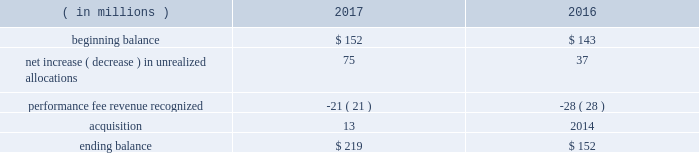When the likelihood of clawback is considered mathematically improbable .
The company records a deferred carried interest liability to the extent it receives cash or capital allocations related to carried interest prior to meeting the revenue recognition criteria .
At december 31 , 2017 and 2016 , the company had $ 219 million and $ 152 million , respectively , of deferred carried interest recorded in other liabilities/other liabilities of consolidated vies on the consolidated statements of financial condition .
A portion of the deferred carried interest liability will be paid to certain employees .
The ultimate timing of the recognition of performance fee revenue , if any , for these products is unknown .
The table presents changes in the deferred carried interest liability ( including the portion related to consolidated vies ) for 2017 and 2016: .
For 2017 , 2016 and 2015 , performance fee revenue ( which included recognized carried interest ) totaled $ 594 million , $ 295 million and $ 621 million , respectively .
Fees earned for technology and risk management revenue are recorded as services are performed and are generally determined using the value of positions on the aladdin platform or on a fixed-rate basis .
For 2017 , 2016 and 2016 , technology and risk management revenue totaled $ 677 million , $ 595 million and $ 528 million , respectively .
Adjustments to revenue arising from initial estimates recorded historically have been immaterial since the majority of blackrock 2019s investment advisory and administration revenue is calculated based on aum and since the company does not record performance fee revenue until performance thresholds have been exceeded and the likelihood of clawback is mathematically improbable .
Accounting developments recent accounting pronouncements not yet adopted .
Revenue from contracts with customers .
In may 2014 , the financial accounting standards board ( 201cfasb 201d ) issued accounting standards update ( 201casu 201d ) 2014-09 , revenue from contracts with customers ( 201casu 2014-09 201d ) .
Asu 2014-09 outlines a single comprehensive model for entities to use in accounting for revenue arising from contracts with customers and supersedes most current revenue recognition guidance , including industry-specific guidance .
The guidance also changes the accounting for certain contract costs and revises the criteria for determining if an entity is acting as a principal or agent in certain arrangements .
The key changes in the standard that impact the company 2019s revenue recognition relate to the presentation of certain revenue contracts and associated contract costs .
The most significant of these changes relates to the presentation of certain distribution costs , which are currently presented net against revenues ( contra-revenue ) and will be presented as an expense on a gross basis .
The company adopted asu 2014-09 effective january 1 , 2018 on a full retrospective basis , which will require 2016 and 2017 to be restated in future filings .
The cumulative effect adjustment to the 2016 opening retained earnings was not material .
The company currently expects the net gross up to revenue to be approximately $ 1 billion with a corresponding gross up to expense for both 2016 and 2017 .
Consequently , the company expects its gaap operating margin to decline upon adoption due to the gross up of revenue .
However , no material impact is expected on the company 2019s as adjusted operating margin .
For accounting pronouncements that the company adopted during the year ended december 31 , 2017 and for additional recent accounting pronouncements not yet adopted , see note 2 , significant accounting policies , in the consolidated financial statements contained in part ii , item 8 of this filing .
Item 7a .
Quantitative and qualitative disclosures about market risk aum market price risk .
Blackrock 2019s investment advisory and administration fees are primarily comprised of fees based on a percentage of the value of aum and , in some cases , performance fees expressed as a percentage of the returns realized on aum .
At december 31 , 2017 , the majority of the company 2019s investment advisory and administration fees were based on average or period end aum of the applicable investment funds or separate accounts .
Movements in equity market prices , interest rates/credit spreads , foreign exchange rates or all three could cause the value of aum to decline , which would result in lower investment advisory and administration fees .
Corporate investments portfolio risks .
As a leading investment management firm , blackrock devotes significant resources across all of its operations to identifying , measuring , monitoring , managing and analyzing market and operating risks , including the management and oversight of its own investment portfolio .
The board of directors of the company has adopted guidelines for the review of investments to be made by the company , requiring , among other things , that investments be reviewed by certain senior officers of the company , and that certain investments may be referred to the audit committee or the board of directors , depending on the circumstances , for approval .
In the normal course of its business , blackrock is exposed to equity market price risk , interest rate/credit spread risk and foreign exchange rate risk associated with its corporate investments .
Blackrock has investments primarily in sponsored investment products that invest in a variety of asset classes , including real assets , private equity and hedge funds .
Investments generally are made for co-investment purposes , to establish a performance track record , to hedge exposure to certain deferred compensation plans or for regulatory purposes .
Currently , the company has a seed capital hedging program in which it enters into swaps to hedge market and interest rate exposure to certain investments .
At december 31 , 2017 , the company had outstanding total return swaps with an aggregate notional value of approximately $ 587 million .
At december 31 , 2017 , there were no outstanding interest rate swaps. .
What was the total increase from acquisitions and unrealized allocations ? in millions $ .? 
Computations: (13 + (75 + 37))
Answer: 125.0. When the likelihood of clawback is considered mathematically improbable .
The company records a deferred carried interest liability to the extent it receives cash or capital allocations related to carried interest prior to meeting the revenue recognition criteria .
At december 31 , 2017 and 2016 , the company had $ 219 million and $ 152 million , respectively , of deferred carried interest recorded in other liabilities/other liabilities of consolidated vies on the consolidated statements of financial condition .
A portion of the deferred carried interest liability will be paid to certain employees .
The ultimate timing of the recognition of performance fee revenue , if any , for these products is unknown .
The table presents changes in the deferred carried interest liability ( including the portion related to consolidated vies ) for 2017 and 2016: .
For 2017 , 2016 and 2015 , performance fee revenue ( which included recognized carried interest ) totaled $ 594 million , $ 295 million and $ 621 million , respectively .
Fees earned for technology and risk management revenue are recorded as services are performed and are generally determined using the value of positions on the aladdin platform or on a fixed-rate basis .
For 2017 , 2016 and 2016 , technology and risk management revenue totaled $ 677 million , $ 595 million and $ 528 million , respectively .
Adjustments to revenue arising from initial estimates recorded historically have been immaterial since the majority of blackrock 2019s investment advisory and administration revenue is calculated based on aum and since the company does not record performance fee revenue until performance thresholds have been exceeded and the likelihood of clawback is mathematically improbable .
Accounting developments recent accounting pronouncements not yet adopted .
Revenue from contracts with customers .
In may 2014 , the financial accounting standards board ( 201cfasb 201d ) issued accounting standards update ( 201casu 201d ) 2014-09 , revenue from contracts with customers ( 201casu 2014-09 201d ) .
Asu 2014-09 outlines a single comprehensive model for entities to use in accounting for revenue arising from contracts with customers and supersedes most current revenue recognition guidance , including industry-specific guidance .
The guidance also changes the accounting for certain contract costs and revises the criteria for determining if an entity is acting as a principal or agent in certain arrangements .
The key changes in the standard that impact the company 2019s revenue recognition relate to the presentation of certain revenue contracts and associated contract costs .
The most significant of these changes relates to the presentation of certain distribution costs , which are currently presented net against revenues ( contra-revenue ) and will be presented as an expense on a gross basis .
The company adopted asu 2014-09 effective january 1 , 2018 on a full retrospective basis , which will require 2016 and 2017 to be restated in future filings .
The cumulative effect adjustment to the 2016 opening retained earnings was not material .
The company currently expects the net gross up to revenue to be approximately $ 1 billion with a corresponding gross up to expense for both 2016 and 2017 .
Consequently , the company expects its gaap operating margin to decline upon adoption due to the gross up of revenue .
However , no material impact is expected on the company 2019s as adjusted operating margin .
For accounting pronouncements that the company adopted during the year ended december 31 , 2017 and for additional recent accounting pronouncements not yet adopted , see note 2 , significant accounting policies , in the consolidated financial statements contained in part ii , item 8 of this filing .
Item 7a .
Quantitative and qualitative disclosures about market risk aum market price risk .
Blackrock 2019s investment advisory and administration fees are primarily comprised of fees based on a percentage of the value of aum and , in some cases , performance fees expressed as a percentage of the returns realized on aum .
At december 31 , 2017 , the majority of the company 2019s investment advisory and administration fees were based on average or period end aum of the applicable investment funds or separate accounts .
Movements in equity market prices , interest rates/credit spreads , foreign exchange rates or all three could cause the value of aum to decline , which would result in lower investment advisory and administration fees .
Corporate investments portfolio risks .
As a leading investment management firm , blackrock devotes significant resources across all of its operations to identifying , measuring , monitoring , managing and analyzing market and operating risks , including the management and oversight of its own investment portfolio .
The board of directors of the company has adopted guidelines for the review of investments to be made by the company , requiring , among other things , that investments be reviewed by certain senior officers of the company , and that certain investments may be referred to the audit committee or the board of directors , depending on the circumstances , for approval .
In the normal course of its business , blackrock is exposed to equity market price risk , interest rate/credit spread risk and foreign exchange rate risk associated with its corporate investments .
Blackrock has investments primarily in sponsored investment products that invest in a variety of asset classes , including real assets , private equity and hedge funds .
Investments generally are made for co-investment purposes , to establish a performance track record , to hedge exposure to certain deferred compensation plans or for regulatory purposes .
Currently , the company has a seed capital hedging program in which it enters into swaps to hedge market and interest rate exposure to certain investments .
At december 31 , 2017 , the company had outstanding total return swaps with an aggregate notional value of approximately $ 587 million .
At december 31 , 2017 , there were no outstanding interest rate swaps. .
What is the growth rate in revenue related technology and risk management from 2016 to 2017? 
Computations: ((677 - 595) / 595)
Answer: 0.13782. 